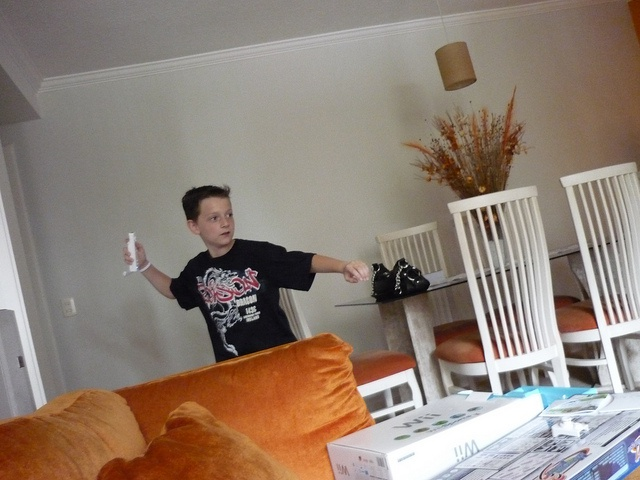Describe the objects in this image and their specific colors. I can see couch in gray, brown, maroon, and red tones, people in gray, black, and darkgray tones, chair in gray, lightgray, and darkgray tones, chair in gray, lightgray, and darkgray tones, and dining table in gray, darkgray, and black tones in this image. 